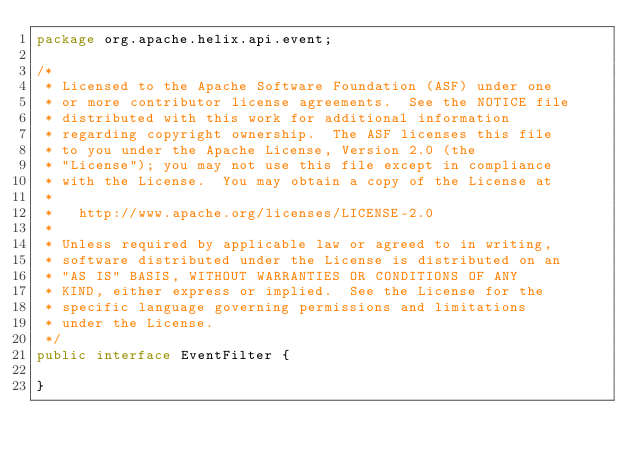Convert code to text. <code><loc_0><loc_0><loc_500><loc_500><_Java_>package org.apache.helix.api.event;

/*
 * Licensed to the Apache Software Foundation (ASF) under one
 * or more contributor license agreements.  See the NOTICE file
 * distributed with this work for additional information
 * regarding copyright ownership.  The ASF licenses this file
 * to you under the Apache License, Version 2.0 (the
 * "License"); you may not use this file except in compliance
 * with the License.  You may obtain a copy of the License at
 *
 *   http://www.apache.org/licenses/LICENSE-2.0
 *
 * Unless required by applicable law or agreed to in writing,
 * software distributed under the License is distributed on an
 * "AS IS" BASIS, WITHOUT WARRANTIES OR CONDITIONS OF ANY
 * KIND, either express or implied.  See the License for the
 * specific language governing permissions and limitations
 * under the License.
 */
public interface EventFilter {

}
</code> 